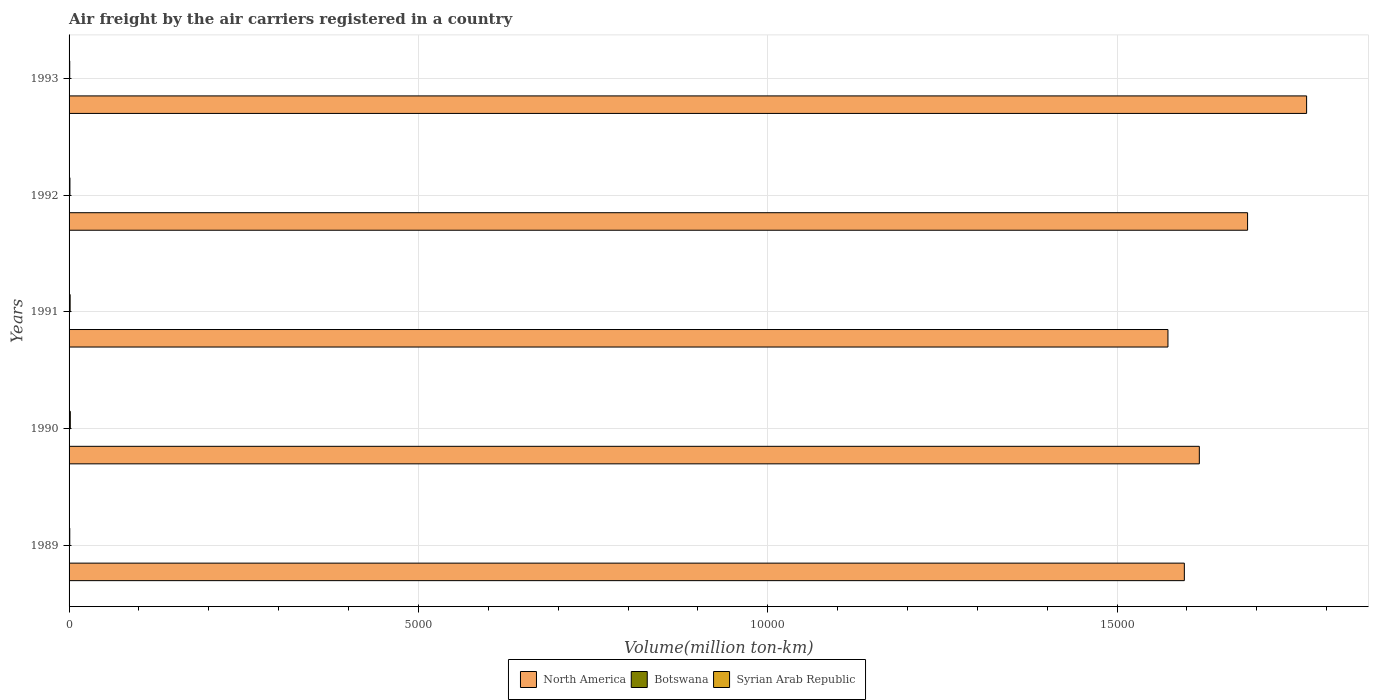How many different coloured bars are there?
Make the answer very short. 3. How many groups of bars are there?
Ensure brevity in your answer.  5. Are the number of bars per tick equal to the number of legend labels?
Ensure brevity in your answer.  Yes. Are the number of bars on each tick of the Y-axis equal?
Make the answer very short. Yes. How many bars are there on the 3rd tick from the bottom?
Offer a very short reply. 3. What is the label of the 5th group of bars from the top?
Make the answer very short. 1989. In how many cases, is the number of bars for a given year not equal to the number of legend labels?
Give a very brief answer. 0. What is the volume of the air carriers in Syrian Arab Republic in 1992?
Your answer should be compact. 12.5. Across all years, what is the maximum volume of the air carriers in North America?
Make the answer very short. 1.77e+04. Across all years, what is the minimum volume of the air carriers in North America?
Your answer should be very brief. 1.57e+04. In which year was the volume of the air carriers in Syrian Arab Republic maximum?
Your answer should be compact. 1990. What is the total volume of the air carriers in Botswana in the graph?
Keep it short and to the point. 5.3. What is the difference between the volume of the air carriers in Botswana in 1990 and that in 1993?
Offer a terse response. 2.3. What is the difference between the volume of the air carriers in Syrian Arab Republic in 1993 and the volume of the air carriers in Botswana in 1992?
Make the answer very short. 8.9. What is the average volume of the air carriers in North America per year?
Offer a terse response. 1.65e+04. In the year 1992, what is the difference between the volume of the air carriers in Syrian Arab Republic and volume of the air carriers in North America?
Make the answer very short. -1.69e+04. In how many years, is the volume of the air carriers in Syrian Arab Republic greater than 10000 million ton-km?
Ensure brevity in your answer.  0. What is the ratio of the volume of the air carriers in Syrian Arab Republic in 1989 to that in 1990?
Your response must be concise. 0.56. What is the difference between the highest and the second highest volume of the air carriers in Botswana?
Give a very brief answer. 2.3. What is the difference between the highest and the lowest volume of the air carriers in Botswana?
Your answer should be very brief. 2.7. In how many years, is the volume of the air carriers in Syrian Arab Republic greater than the average volume of the air carriers in Syrian Arab Republic taken over all years?
Your answer should be compact. 2. Is the sum of the volume of the air carriers in Syrian Arab Republic in 1990 and 1992 greater than the maximum volume of the air carriers in Botswana across all years?
Give a very brief answer. Yes. What does the 1st bar from the top in 1993 represents?
Make the answer very short. Syrian Arab Republic. What does the 2nd bar from the bottom in 1992 represents?
Keep it short and to the point. Botswana. Is it the case that in every year, the sum of the volume of the air carriers in Botswana and volume of the air carriers in Syrian Arab Republic is greater than the volume of the air carriers in North America?
Keep it short and to the point. No. Are all the bars in the graph horizontal?
Provide a succinct answer. Yes. Are the values on the major ticks of X-axis written in scientific E-notation?
Offer a terse response. No. Does the graph contain any zero values?
Ensure brevity in your answer.  No. Where does the legend appear in the graph?
Your answer should be very brief. Bottom center. How many legend labels are there?
Offer a terse response. 3. What is the title of the graph?
Provide a short and direct response. Air freight by the air carriers registered in a country. What is the label or title of the X-axis?
Make the answer very short. Volume(million ton-km). What is the Volume(million ton-km) of North America in 1989?
Your response must be concise. 1.60e+04. What is the Volume(million ton-km) in Botswana in 1989?
Your answer should be very brief. 0.4. What is the Volume(million ton-km) of Syrian Arab Republic in 1989?
Offer a very short reply. 10. What is the Volume(million ton-km) in North America in 1990?
Provide a short and direct response. 1.62e+04. What is the Volume(million ton-km) in Botswana in 1990?
Offer a terse response. 3.1. What is the Volume(million ton-km) in Syrian Arab Republic in 1990?
Your answer should be very brief. 17.7. What is the Volume(million ton-km) in North America in 1991?
Your response must be concise. 1.57e+04. What is the Volume(million ton-km) of Botswana in 1991?
Give a very brief answer. 0.4. What is the Volume(million ton-km) in Syrian Arab Republic in 1991?
Your answer should be very brief. 15.4. What is the Volume(million ton-km) of North America in 1992?
Offer a very short reply. 1.69e+04. What is the Volume(million ton-km) in Botswana in 1992?
Make the answer very short. 0.6. What is the Volume(million ton-km) of Syrian Arab Republic in 1992?
Provide a short and direct response. 12.5. What is the Volume(million ton-km) in North America in 1993?
Your answer should be very brief. 1.77e+04. What is the Volume(million ton-km) in Botswana in 1993?
Your response must be concise. 0.8. Across all years, what is the maximum Volume(million ton-km) in North America?
Provide a succinct answer. 1.77e+04. Across all years, what is the maximum Volume(million ton-km) of Botswana?
Your answer should be very brief. 3.1. Across all years, what is the maximum Volume(million ton-km) of Syrian Arab Republic?
Your answer should be very brief. 17.7. Across all years, what is the minimum Volume(million ton-km) of North America?
Keep it short and to the point. 1.57e+04. Across all years, what is the minimum Volume(million ton-km) of Botswana?
Offer a terse response. 0.4. Across all years, what is the minimum Volume(million ton-km) of Syrian Arab Republic?
Provide a short and direct response. 9.5. What is the total Volume(million ton-km) in North America in the graph?
Your answer should be very brief. 8.24e+04. What is the total Volume(million ton-km) of Botswana in the graph?
Keep it short and to the point. 5.3. What is the total Volume(million ton-km) in Syrian Arab Republic in the graph?
Offer a very short reply. 65.1. What is the difference between the Volume(million ton-km) in North America in 1989 and that in 1990?
Keep it short and to the point. -214.4. What is the difference between the Volume(million ton-km) in North America in 1989 and that in 1991?
Provide a succinct answer. 234.7. What is the difference between the Volume(million ton-km) of Botswana in 1989 and that in 1991?
Your answer should be compact. 0. What is the difference between the Volume(million ton-km) of Syrian Arab Republic in 1989 and that in 1991?
Ensure brevity in your answer.  -5.4. What is the difference between the Volume(million ton-km) of North America in 1989 and that in 1992?
Make the answer very short. -905. What is the difference between the Volume(million ton-km) of North America in 1989 and that in 1993?
Keep it short and to the point. -1749.9. What is the difference between the Volume(million ton-km) in Botswana in 1989 and that in 1993?
Your answer should be compact. -0.4. What is the difference between the Volume(million ton-km) of Syrian Arab Republic in 1989 and that in 1993?
Your answer should be very brief. 0.5. What is the difference between the Volume(million ton-km) in North America in 1990 and that in 1991?
Your response must be concise. 449.1. What is the difference between the Volume(million ton-km) in Syrian Arab Republic in 1990 and that in 1991?
Keep it short and to the point. 2.3. What is the difference between the Volume(million ton-km) in North America in 1990 and that in 1992?
Your answer should be very brief. -690.6. What is the difference between the Volume(million ton-km) in North America in 1990 and that in 1993?
Give a very brief answer. -1535.5. What is the difference between the Volume(million ton-km) of Syrian Arab Republic in 1990 and that in 1993?
Offer a very short reply. 8.2. What is the difference between the Volume(million ton-km) of North America in 1991 and that in 1992?
Your response must be concise. -1139.7. What is the difference between the Volume(million ton-km) of North America in 1991 and that in 1993?
Make the answer very short. -1984.6. What is the difference between the Volume(million ton-km) of Syrian Arab Republic in 1991 and that in 1993?
Your answer should be compact. 5.9. What is the difference between the Volume(million ton-km) in North America in 1992 and that in 1993?
Offer a very short reply. -844.9. What is the difference between the Volume(million ton-km) in North America in 1989 and the Volume(million ton-km) in Botswana in 1990?
Keep it short and to the point. 1.60e+04. What is the difference between the Volume(million ton-km) in North America in 1989 and the Volume(million ton-km) in Syrian Arab Republic in 1990?
Ensure brevity in your answer.  1.59e+04. What is the difference between the Volume(million ton-km) in Botswana in 1989 and the Volume(million ton-km) in Syrian Arab Republic in 1990?
Offer a terse response. -17.3. What is the difference between the Volume(million ton-km) of North America in 1989 and the Volume(million ton-km) of Botswana in 1991?
Your response must be concise. 1.60e+04. What is the difference between the Volume(million ton-km) in North America in 1989 and the Volume(million ton-km) in Syrian Arab Republic in 1991?
Your answer should be compact. 1.59e+04. What is the difference between the Volume(million ton-km) in North America in 1989 and the Volume(million ton-km) in Botswana in 1992?
Your answer should be compact. 1.60e+04. What is the difference between the Volume(million ton-km) of North America in 1989 and the Volume(million ton-km) of Syrian Arab Republic in 1992?
Keep it short and to the point. 1.59e+04. What is the difference between the Volume(million ton-km) in North America in 1989 and the Volume(million ton-km) in Botswana in 1993?
Keep it short and to the point. 1.60e+04. What is the difference between the Volume(million ton-km) in North America in 1989 and the Volume(million ton-km) in Syrian Arab Republic in 1993?
Your answer should be very brief. 1.60e+04. What is the difference between the Volume(million ton-km) of Botswana in 1989 and the Volume(million ton-km) of Syrian Arab Republic in 1993?
Give a very brief answer. -9.1. What is the difference between the Volume(million ton-km) of North America in 1990 and the Volume(million ton-km) of Botswana in 1991?
Ensure brevity in your answer.  1.62e+04. What is the difference between the Volume(million ton-km) of North America in 1990 and the Volume(million ton-km) of Syrian Arab Republic in 1991?
Your answer should be very brief. 1.62e+04. What is the difference between the Volume(million ton-km) of Botswana in 1990 and the Volume(million ton-km) of Syrian Arab Republic in 1991?
Offer a terse response. -12.3. What is the difference between the Volume(million ton-km) of North America in 1990 and the Volume(million ton-km) of Botswana in 1992?
Offer a very short reply. 1.62e+04. What is the difference between the Volume(million ton-km) of North America in 1990 and the Volume(million ton-km) of Syrian Arab Republic in 1992?
Provide a succinct answer. 1.62e+04. What is the difference between the Volume(million ton-km) of North America in 1990 and the Volume(million ton-km) of Botswana in 1993?
Offer a very short reply. 1.62e+04. What is the difference between the Volume(million ton-km) of North America in 1990 and the Volume(million ton-km) of Syrian Arab Republic in 1993?
Ensure brevity in your answer.  1.62e+04. What is the difference between the Volume(million ton-km) of North America in 1991 and the Volume(million ton-km) of Botswana in 1992?
Make the answer very short. 1.57e+04. What is the difference between the Volume(million ton-km) in North America in 1991 and the Volume(million ton-km) in Syrian Arab Republic in 1992?
Your response must be concise. 1.57e+04. What is the difference between the Volume(million ton-km) of North America in 1991 and the Volume(million ton-km) of Botswana in 1993?
Your response must be concise. 1.57e+04. What is the difference between the Volume(million ton-km) of North America in 1991 and the Volume(million ton-km) of Syrian Arab Republic in 1993?
Make the answer very short. 1.57e+04. What is the difference between the Volume(million ton-km) in Botswana in 1991 and the Volume(million ton-km) in Syrian Arab Republic in 1993?
Provide a succinct answer. -9.1. What is the difference between the Volume(million ton-km) in North America in 1992 and the Volume(million ton-km) in Botswana in 1993?
Offer a very short reply. 1.69e+04. What is the difference between the Volume(million ton-km) in North America in 1992 and the Volume(million ton-km) in Syrian Arab Republic in 1993?
Offer a very short reply. 1.69e+04. What is the difference between the Volume(million ton-km) in Botswana in 1992 and the Volume(million ton-km) in Syrian Arab Republic in 1993?
Offer a very short reply. -8.9. What is the average Volume(million ton-km) in North America per year?
Ensure brevity in your answer.  1.65e+04. What is the average Volume(million ton-km) of Botswana per year?
Keep it short and to the point. 1.06. What is the average Volume(million ton-km) in Syrian Arab Republic per year?
Make the answer very short. 13.02. In the year 1989, what is the difference between the Volume(million ton-km) in North America and Volume(million ton-km) in Botswana?
Provide a succinct answer. 1.60e+04. In the year 1989, what is the difference between the Volume(million ton-km) of North America and Volume(million ton-km) of Syrian Arab Republic?
Make the answer very short. 1.60e+04. In the year 1989, what is the difference between the Volume(million ton-km) of Botswana and Volume(million ton-km) of Syrian Arab Republic?
Your response must be concise. -9.6. In the year 1990, what is the difference between the Volume(million ton-km) in North America and Volume(million ton-km) in Botswana?
Your answer should be compact. 1.62e+04. In the year 1990, what is the difference between the Volume(million ton-km) of North America and Volume(million ton-km) of Syrian Arab Republic?
Ensure brevity in your answer.  1.62e+04. In the year 1990, what is the difference between the Volume(million ton-km) in Botswana and Volume(million ton-km) in Syrian Arab Republic?
Give a very brief answer. -14.6. In the year 1991, what is the difference between the Volume(million ton-km) of North America and Volume(million ton-km) of Botswana?
Keep it short and to the point. 1.57e+04. In the year 1991, what is the difference between the Volume(million ton-km) in North America and Volume(million ton-km) in Syrian Arab Republic?
Offer a very short reply. 1.57e+04. In the year 1991, what is the difference between the Volume(million ton-km) in Botswana and Volume(million ton-km) in Syrian Arab Republic?
Provide a short and direct response. -15. In the year 1992, what is the difference between the Volume(million ton-km) of North America and Volume(million ton-km) of Botswana?
Your response must be concise. 1.69e+04. In the year 1992, what is the difference between the Volume(million ton-km) in North America and Volume(million ton-km) in Syrian Arab Republic?
Provide a succinct answer. 1.69e+04. In the year 1993, what is the difference between the Volume(million ton-km) in North America and Volume(million ton-km) in Botswana?
Your answer should be very brief. 1.77e+04. In the year 1993, what is the difference between the Volume(million ton-km) in North America and Volume(million ton-km) in Syrian Arab Republic?
Provide a succinct answer. 1.77e+04. What is the ratio of the Volume(million ton-km) in North America in 1989 to that in 1990?
Your answer should be compact. 0.99. What is the ratio of the Volume(million ton-km) in Botswana in 1989 to that in 1990?
Give a very brief answer. 0.13. What is the ratio of the Volume(million ton-km) of Syrian Arab Republic in 1989 to that in 1990?
Provide a succinct answer. 0.56. What is the ratio of the Volume(million ton-km) in North America in 1989 to that in 1991?
Make the answer very short. 1.01. What is the ratio of the Volume(million ton-km) of Botswana in 1989 to that in 1991?
Offer a very short reply. 1. What is the ratio of the Volume(million ton-km) in Syrian Arab Republic in 1989 to that in 1991?
Your response must be concise. 0.65. What is the ratio of the Volume(million ton-km) in North America in 1989 to that in 1992?
Your response must be concise. 0.95. What is the ratio of the Volume(million ton-km) in Botswana in 1989 to that in 1992?
Offer a very short reply. 0.67. What is the ratio of the Volume(million ton-km) of North America in 1989 to that in 1993?
Ensure brevity in your answer.  0.9. What is the ratio of the Volume(million ton-km) in Botswana in 1989 to that in 1993?
Keep it short and to the point. 0.5. What is the ratio of the Volume(million ton-km) of Syrian Arab Republic in 1989 to that in 1993?
Your answer should be compact. 1.05. What is the ratio of the Volume(million ton-km) in North America in 1990 to that in 1991?
Give a very brief answer. 1.03. What is the ratio of the Volume(million ton-km) of Botswana in 1990 to that in 1991?
Ensure brevity in your answer.  7.75. What is the ratio of the Volume(million ton-km) in Syrian Arab Republic in 1990 to that in 1991?
Ensure brevity in your answer.  1.15. What is the ratio of the Volume(million ton-km) in North America in 1990 to that in 1992?
Your response must be concise. 0.96. What is the ratio of the Volume(million ton-km) of Botswana in 1990 to that in 1992?
Give a very brief answer. 5.17. What is the ratio of the Volume(million ton-km) of Syrian Arab Republic in 1990 to that in 1992?
Your answer should be compact. 1.42. What is the ratio of the Volume(million ton-km) in North America in 1990 to that in 1993?
Offer a very short reply. 0.91. What is the ratio of the Volume(million ton-km) of Botswana in 1990 to that in 1993?
Your answer should be very brief. 3.88. What is the ratio of the Volume(million ton-km) of Syrian Arab Republic in 1990 to that in 1993?
Provide a short and direct response. 1.86. What is the ratio of the Volume(million ton-km) of North America in 1991 to that in 1992?
Make the answer very short. 0.93. What is the ratio of the Volume(million ton-km) of Syrian Arab Republic in 1991 to that in 1992?
Your answer should be compact. 1.23. What is the ratio of the Volume(million ton-km) in North America in 1991 to that in 1993?
Provide a succinct answer. 0.89. What is the ratio of the Volume(million ton-km) in Botswana in 1991 to that in 1993?
Make the answer very short. 0.5. What is the ratio of the Volume(million ton-km) of Syrian Arab Republic in 1991 to that in 1993?
Your response must be concise. 1.62. What is the ratio of the Volume(million ton-km) in North America in 1992 to that in 1993?
Provide a short and direct response. 0.95. What is the ratio of the Volume(million ton-km) of Syrian Arab Republic in 1992 to that in 1993?
Your response must be concise. 1.32. What is the difference between the highest and the second highest Volume(million ton-km) in North America?
Your response must be concise. 844.9. What is the difference between the highest and the lowest Volume(million ton-km) of North America?
Provide a succinct answer. 1984.6. What is the difference between the highest and the lowest Volume(million ton-km) of Botswana?
Provide a succinct answer. 2.7. What is the difference between the highest and the lowest Volume(million ton-km) of Syrian Arab Republic?
Ensure brevity in your answer.  8.2. 